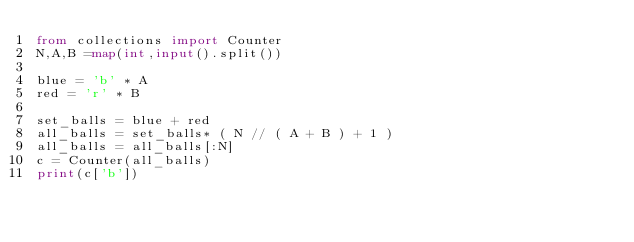Convert code to text. <code><loc_0><loc_0><loc_500><loc_500><_Python_>from collections import Counter
N,A,B =map(int,input().split()) 

blue = 'b' * A
red = 'r' * B

set_balls = blue + red
all_balls = set_balls* ( N // ( A + B ) + 1 )
all_balls = all_balls[:N]
c = Counter(all_balls)
print(c['b'])
</code> 